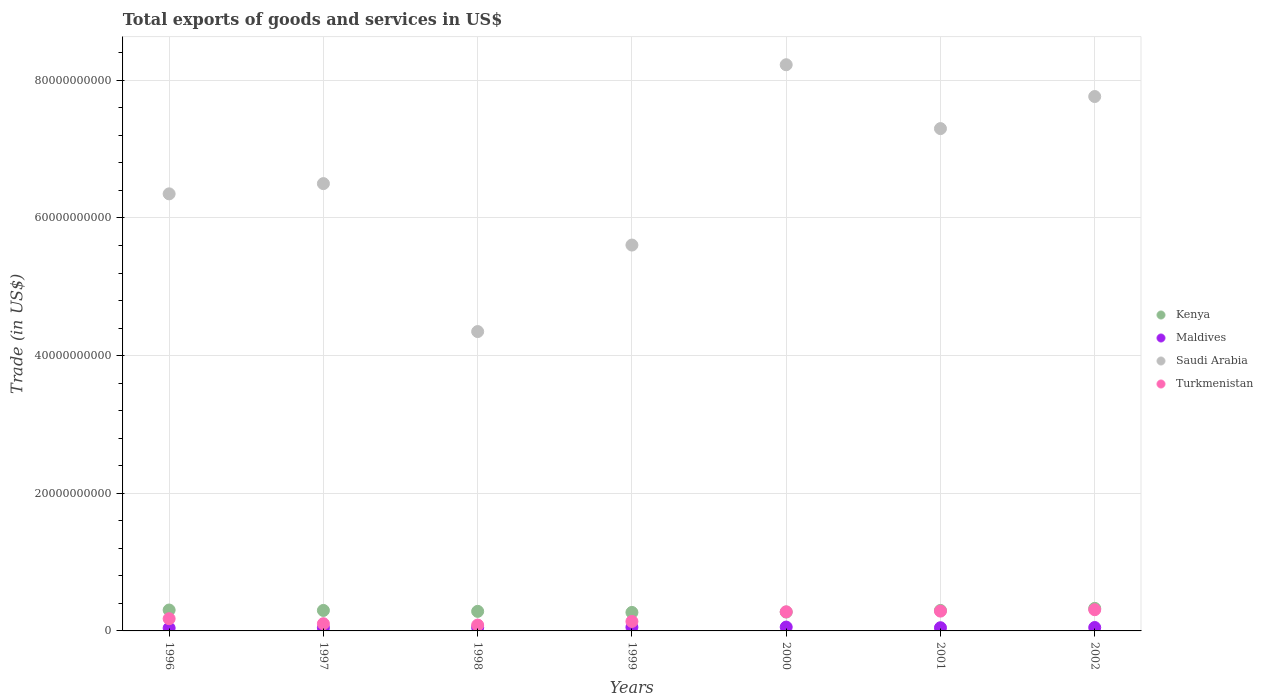Is the number of dotlines equal to the number of legend labels?
Provide a short and direct response. Yes. What is the total exports of goods and services in Kenya in 1996?
Your response must be concise. 3.04e+09. Across all years, what is the maximum total exports of goods and services in Turkmenistan?
Your answer should be very brief. 3.08e+09. Across all years, what is the minimum total exports of goods and services in Maldives?
Provide a short and direct response. 4.13e+08. In which year was the total exports of goods and services in Kenya maximum?
Your response must be concise. 2002. In which year was the total exports of goods and services in Kenya minimum?
Your answer should be very brief. 1999. What is the total total exports of goods and services in Maldives in the graph?
Ensure brevity in your answer.  3.43e+09. What is the difference between the total exports of goods and services in Turkmenistan in 1998 and that in 2000?
Make the answer very short. -1.92e+09. What is the difference between the total exports of goods and services in Maldives in 1998 and the total exports of goods and services in Saudi Arabia in 1996?
Ensure brevity in your answer.  -6.30e+1. What is the average total exports of goods and services in Saudi Arabia per year?
Your answer should be very brief. 6.58e+1. In the year 2002, what is the difference between the total exports of goods and services in Saudi Arabia and total exports of goods and services in Kenya?
Your response must be concise. 7.44e+1. In how many years, is the total exports of goods and services in Turkmenistan greater than 28000000000 US$?
Your answer should be compact. 0. What is the ratio of the total exports of goods and services in Maldives in 1997 to that in 1998?
Provide a succinct answer. 0.93. Is the total exports of goods and services in Kenya in 1999 less than that in 2002?
Provide a succinct answer. Yes. What is the difference between the highest and the second highest total exports of goods and services in Saudi Arabia?
Make the answer very short. 4.62e+09. What is the difference between the highest and the lowest total exports of goods and services in Turkmenistan?
Your response must be concise. 2.23e+09. In how many years, is the total exports of goods and services in Saudi Arabia greater than the average total exports of goods and services in Saudi Arabia taken over all years?
Make the answer very short. 3. Is the sum of the total exports of goods and services in Maldives in 1999 and 2001 greater than the maximum total exports of goods and services in Turkmenistan across all years?
Ensure brevity in your answer.  No. Is it the case that in every year, the sum of the total exports of goods and services in Kenya and total exports of goods and services in Saudi Arabia  is greater than the sum of total exports of goods and services in Maldives and total exports of goods and services in Turkmenistan?
Your answer should be very brief. Yes. Are the values on the major ticks of Y-axis written in scientific E-notation?
Offer a terse response. No. Does the graph contain grids?
Ensure brevity in your answer.  Yes. Where does the legend appear in the graph?
Keep it short and to the point. Center right. How are the legend labels stacked?
Offer a terse response. Vertical. What is the title of the graph?
Your answer should be compact. Total exports of goods and services in US$. What is the label or title of the Y-axis?
Provide a succinct answer. Trade (in US$). What is the Trade (in US$) in Kenya in 1996?
Provide a short and direct response. 3.04e+09. What is the Trade (in US$) of Maldives in 1996?
Give a very brief answer. 4.13e+08. What is the Trade (in US$) of Saudi Arabia in 1996?
Your response must be concise. 6.35e+1. What is the Trade (in US$) in Turkmenistan in 1996?
Your answer should be compact. 1.77e+09. What is the Trade (in US$) of Kenya in 1997?
Your response must be concise. 2.98e+09. What is the Trade (in US$) of Maldives in 1997?
Your answer should be very brief. 4.64e+08. What is the Trade (in US$) of Saudi Arabia in 1997?
Your answer should be very brief. 6.50e+1. What is the Trade (in US$) in Turkmenistan in 1997?
Provide a succinct answer. 1.05e+09. What is the Trade (in US$) of Kenya in 1998?
Make the answer very short. 2.84e+09. What is the Trade (in US$) of Maldives in 1998?
Your answer should be compact. 4.99e+08. What is the Trade (in US$) of Saudi Arabia in 1998?
Give a very brief answer. 4.35e+1. What is the Trade (in US$) in Turkmenistan in 1998?
Make the answer very short. 8.51e+08. What is the Trade (in US$) of Kenya in 1999?
Ensure brevity in your answer.  2.69e+09. What is the Trade (in US$) of Maldives in 1999?
Provide a succinct answer. 5.33e+08. What is the Trade (in US$) in Saudi Arabia in 1999?
Ensure brevity in your answer.  5.61e+1. What is the Trade (in US$) in Turkmenistan in 1999?
Ensure brevity in your answer.  1.38e+09. What is the Trade (in US$) in Kenya in 2000?
Make the answer very short. 2.74e+09. What is the Trade (in US$) in Maldives in 2000?
Provide a succinct answer. 5.59e+08. What is the Trade (in US$) of Saudi Arabia in 2000?
Provide a short and direct response. 8.23e+1. What is the Trade (in US$) in Turkmenistan in 2000?
Offer a terse response. 2.77e+09. What is the Trade (in US$) of Kenya in 2001?
Offer a terse response. 2.98e+09. What is the Trade (in US$) of Maldives in 2001?
Offer a terse response. 4.64e+08. What is the Trade (in US$) in Saudi Arabia in 2001?
Give a very brief answer. 7.30e+1. What is the Trade (in US$) in Turkmenistan in 2001?
Offer a terse response. 2.88e+09. What is the Trade (in US$) in Kenya in 2002?
Provide a succinct answer. 3.27e+09. What is the Trade (in US$) in Maldives in 2002?
Give a very brief answer. 4.95e+08. What is the Trade (in US$) in Saudi Arabia in 2002?
Give a very brief answer. 7.76e+1. What is the Trade (in US$) in Turkmenistan in 2002?
Your response must be concise. 3.08e+09. Across all years, what is the maximum Trade (in US$) in Kenya?
Your answer should be compact. 3.27e+09. Across all years, what is the maximum Trade (in US$) in Maldives?
Offer a very short reply. 5.59e+08. Across all years, what is the maximum Trade (in US$) in Saudi Arabia?
Your answer should be compact. 8.23e+1. Across all years, what is the maximum Trade (in US$) in Turkmenistan?
Make the answer very short. 3.08e+09. Across all years, what is the minimum Trade (in US$) of Kenya?
Provide a succinct answer. 2.69e+09. Across all years, what is the minimum Trade (in US$) of Maldives?
Ensure brevity in your answer.  4.13e+08. Across all years, what is the minimum Trade (in US$) of Saudi Arabia?
Your answer should be compact. 4.35e+1. Across all years, what is the minimum Trade (in US$) in Turkmenistan?
Offer a terse response. 8.51e+08. What is the total Trade (in US$) of Kenya in the graph?
Keep it short and to the point. 2.05e+1. What is the total Trade (in US$) in Maldives in the graph?
Offer a very short reply. 3.43e+09. What is the total Trade (in US$) in Saudi Arabia in the graph?
Ensure brevity in your answer.  4.61e+11. What is the total Trade (in US$) of Turkmenistan in the graph?
Your answer should be very brief. 1.38e+1. What is the difference between the Trade (in US$) of Kenya in 1996 and that in 1997?
Make the answer very short. 6.01e+07. What is the difference between the Trade (in US$) in Maldives in 1996 and that in 1997?
Give a very brief answer. -5.06e+07. What is the difference between the Trade (in US$) in Saudi Arabia in 1996 and that in 1997?
Keep it short and to the point. -1.49e+09. What is the difference between the Trade (in US$) in Turkmenistan in 1996 and that in 1997?
Make the answer very short. 7.29e+08. What is the difference between the Trade (in US$) in Kenya in 1996 and that in 1998?
Your answer should be compact. 1.93e+08. What is the difference between the Trade (in US$) in Maldives in 1996 and that in 1998?
Make the answer very short. -8.62e+07. What is the difference between the Trade (in US$) of Saudi Arabia in 1996 and that in 1998?
Your answer should be compact. 2.00e+1. What is the difference between the Trade (in US$) of Turkmenistan in 1996 and that in 1998?
Provide a short and direct response. 9.24e+08. What is the difference between the Trade (in US$) of Kenya in 1996 and that in 1999?
Offer a terse response. 3.49e+08. What is the difference between the Trade (in US$) of Maldives in 1996 and that in 1999?
Ensure brevity in your answer.  -1.20e+08. What is the difference between the Trade (in US$) of Saudi Arabia in 1996 and that in 1999?
Your response must be concise. 7.44e+09. What is the difference between the Trade (in US$) in Turkmenistan in 1996 and that in 1999?
Keep it short and to the point. 3.99e+08. What is the difference between the Trade (in US$) in Kenya in 1996 and that in 2000?
Ensure brevity in your answer.  2.93e+08. What is the difference between the Trade (in US$) in Maldives in 1996 and that in 2000?
Ensure brevity in your answer.  -1.46e+08. What is the difference between the Trade (in US$) in Saudi Arabia in 1996 and that in 2000?
Provide a succinct answer. -1.88e+1. What is the difference between the Trade (in US$) of Turkmenistan in 1996 and that in 2000?
Give a very brief answer. -1.00e+09. What is the difference between the Trade (in US$) in Kenya in 1996 and that in 2001?
Offer a very short reply. 5.77e+07. What is the difference between the Trade (in US$) in Maldives in 1996 and that in 2001?
Your answer should be compact. -5.13e+07. What is the difference between the Trade (in US$) in Saudi Arabia in 1996 and that in 2001?
Your response must be concise. -9.48e+09. What is the difference between the Trade (in US$) in Turkmenistan in 1996 and that in 2001?
Offer a very short reply. -1.10e+09. What is the difference between the Trade (in US$) of Kenya in 1996 and that in 2002?
Ensure brevity in your answer.  -2.38e+08. What is the difference between the Trade (in US$) of Maldives in 1996 and that in 2002?
Ensure brevity in your answer.  -8.23e+07. What is the difference between the Trade (in US$) in Saudi Arabia in 1996 and that in 2002?
Make the answer very short. -1.41e+1. What is the difference between the Trade (in US$) in Turkmenistan in 1996 and that in 2002?
Offer a very short reply. -1.31e+09. What is the difference between the Trade (in US$) in Kenya in 1997 and that in 1998?
Make the answer very short. 1.33e+08. What is the difference between the Trade (in US$) of Maldives in 1997 and that in 1998?
Provide a succinct answer. -3.56e+07. What is the difference between the Trade (in US$) in Saudi Arabia in 1997 and that in 1998?
Offer a very short reply. 2.15e+1. What is the difference between the Trade (in US$) in Turkmenistan in 1997 and that in 1998?
Provide a short and direct response. 1.95e+08. What is the difference between the Trade (in US$) in Kenya in 1997 and that in 1999?
Provide a succinct answer. 2.89e+08. What is the difference between the Trade (in US$) in Maldives in 1997 and that in 1999?
Make the answer very short. -6.97e+07. What is the difference between the Trade (in US$) of Saudi Arabia in 1997 and that in 1999?
Offer a very short reply. 8.93e+09. What is the difference between the Trade (in US$) of Turkmenistan in 1997 and that in 1999?
Give a very brief answer. -3.30e+08. What is the difference between the Trade (in US$) of Kenya in 1997 and that in 2000?
Offer a terse response. 2.33e+08. What is the difference between the Trade (in US$) of Maldives in 1997 and that in 2000?
Offer a terse response. -9.50e+07. What is the difference between the Trade (in US$) in Saudi Arabia in 1997 and that in 2000?
Provide a succinct answer. -1.73e+1. What is the difference between the Trade (in US$) of Turkmenistan in 1997 and that in 2000?
Offer a terse response. -1.73e+09. What is the difference between the Trade (in US$) in Kenya in 1997 and that in 2001?
Give a very brief answer. -2.40e+06. What is the difference between the Trade (in US$) of Maldives in 1997 and that in 2001?
Your answer should be compact. -6.95e+05. What is the difference between the Trade (in US$) of Saudi Arabia in 1997 and that in 2001?
Offer a terse response. -7.99e+09. What is the difference between the Trade (in US$) of Turkmenistan in 1997 and that in 2001?
Your answer should be very brief. -1.83e+09. What is the difference between the Trade (in US$) in Kenya in 1997 and that in 2002?
Give a very brief answer. -2.98e+08. What is the difference between the Trade (in US$) in Maldives in 1997 and that in 2002?
Your response must be concise. -3.17e+07. What is the difference between the Trade (in US$) of Saudi Arabia in 1997 and that in 2002?
Make the answer very short. -1.27e+1. What is the difference between the Trade (in US$) in Turkmenistan in 1997 and that in 2002?
Give a very brief answer. -2.04e+09. What is the difference between the Trade (in US$) in Kenya in 1998 and that in 1999?
Your answer should be compact. 1.56e+08. What is the difference between the Trade (in US$) in Maldives in 1998 and that in 1999?
Ensure brevity in your answer.  -3.41e+07. What is the difference between the Trade (in US$) in Saudi Arabia in 1998 and that in 1999?
Your answer should be very brief. -1.26e+1. What is the difference between the Trade (in US$) in Turkmenistan in 1998 and that in 1999?
Make the answer very short. -5.25e+08. What is the difference between the Trade (in US$) in Kenya in 1998 and that in 2000?
Offer a terse response. 9.99e+07. What is the difference between the Trade (in US$) in Maldives in 1998 and that in 2000?
Your answer should be compact. -5.94e+07. What is the difference between the Trade (in US$) of Saudi Arabia in 1998 and that in 2000?
Offer a very short reply. -3.88e+1. What is the difference between the Trade (in US$) of Turkmenistan in 1998 and that in 2000?
Provide a short and direct response. -1.92e+09. What is the difference between the Trade (in US$) in Kenya in 1998 and that in 2001?
Make the answer very short. -1.35e+08. What is the difference between the Trade (in US$) in Maldives in 1998 and that in 2001?
Your answer should be very brief. 3.49e+07. What is the difference between the Trade (in US$) in Saudi Arabia in 1998 and that in 2001?
Your answer should be very brief. -2.95e+1. What is the difference between the Trade (in US$) of Turkmenistan in 1998 and that in 2001?
Your answer should be very brief. -2.03e+09. What is the difference between the Trade (in US$) in Kenya in 1998 and that in 2002?
Provide a succinct answer. -4.31e+08. What is the difference between the Trade (in US$) in Maldives in 1998 and that in 2002?
Ensure brevity in your answer.  3.90e+06. What is the difference between the Trade (in US$) in Saudi Arabia in 1998 and that in 2002?
Your response must be concise. -3.41e+1. What is the difference between the Trade (in US$) of Turkmenistan in 1998 and that in 2002?
Offer a terse response. -2.23e+09. What is the difference between the Trade (in US$) in Kenya in 1999 and that in 2000?
Your answer should be compact. -5.62e+07. What is the difference between the Trade (in US$) of Maldives in 1999 and that in 2000?
Provide a succinct answer. -2.53e+07. What is the difference between the Trade (in US$) of Saudi Arabia in 1999 and that in 2000?
Your answer should be very brief. -2.62e+1. What is the difference between the Trade (in US$) in Turkmenistan in 1999 and that in 2000?
Offer a terse response. -1.40e+09. What is the difference between the Trade (in US$) in Kenya in 1999 and that in 2001?
Give a very brief answer. -2.91e+08. What is the difference between the Trade (in US$) of Maldives in 1999 and that in 2001?
Keep it short and to the point. 6.90e+07. What is the difference between the Trade (in US$) of Saudi Arabia in 1999 and that in 2001?
Your response must be concise. -1.69e+1. What is the difference between the Trade (in US$) of Turkmenistan in 1999 and that in 2001?
Ensure brevity in your answer.  -1.50e+09. What is the difference between the Trade (in US$) of Kenya in 1999 and that in 2002?
Provide a succinct answer. -5.87e+08. What is the difference between the Trade (in US$) in Maldives in 1999 and that in 2002?
Keep it short and to the point. 3.80e+07. What is the difference between the Trade (in US$) in Saudi Arabia in 1999 and that in 2002?
Your answer should be very brief. -2.16e+1. What is the difference between the Trade (in US$) in Turkmenistan in 1999 and that in 2002?
Provide a succinct answer. -1.71e+09. What is the difference between the Trade (in US$) in Kenya in 2000 and that in 2001?
Keep it short and to the point. -2.35e+08. What is the difference between the Trade (in US$) in Maldives in 2000 and that in 2001?
Give a very brief answer. 9.43e+07. What is the difference between the Trade (in US$) in Saudi Arabia in 2000 and that in 2001?
Ensure brevity in your answer.  9.28e+09. What is the difference between the Trade (in US$) of Turkmenistan in 2000 and that in 2001?
Keep it short and to the point. -1.03e+08. What is the difference between the Trade (in US$) in Kenya in 2000 and that in 2002?
Your answer should be compact. -5.31e+08. What is the difference between the Trade (in US$) of Maldives in 2000 and that in 2002?
Keep it short and to the point. 6.33e+07. What is the difference between the Trade (in US$) in Saudi Arabia in 2000 and that in 2002?
Your response must be concise. 4.62e+09. What is the difference between the Trade (in US$) in Turkmenistan in 2000 and that in 2002?
Give a very brief answer. -3.07e+08. What is the difference between the Trade (in US$) of Kenya in 2001 and that in 2002?
Ensure brevity in your answer.  -2.96e+08. What is the difference between the Trade (in US$) in Maldives in 2001 and that in 2002?
Make the answer very short. -3.10e+07. What is the difference between the Trade (in US$) in Saudi Arabia in 2001 and that in 2002?
Give a very brief answer. -4.66e+09. What is the difference between the Trade (in US$) of Turkmenistan in 2001 and that in 2002?
Your answer should be compact. -2.04e+08. What is the difference between the Trade (in US$) of Kenya in 1996 and the Trade (in US$) of Maldives in 1997?
Your answer should be very brief. 2.57e+09. What is the difference between the Trade (in US$) in Kenya in 1996 and the Trade (in US$) in Saudi Arabia in 1997?
Provide a succinct answer. -6.20e+1. What is the difference between the Trade (in US$) in Kenya in 1996 and the Trade (in US$) in Turkmenistan in 1997?
Your answer should be very brief. 1.99e+09. What is the difference between the Trade (in US$) of Maldives in 1996 and the Trade (in US$) of Saudi Arabia in 1997?
Your answer should be very brief. -6.46e+1. What is the difference between the Trade (in US$) of Maldives in 1996 and the Trade (in US$) of Turkmenistan in 1997?
Your answer should be compact. -6.33e+08. What is the difference between the Trade (in US$) in Saudi Arabia in 1996 and the Trade (in US$) in Turkmenistan in 1997?
Provide a short and direct response. 6.25e+1. What is the difference between the Trade (in US$) of Kenya in 1996 and the Trade (in US$) of Maldives in 1998?
Offer a terse response. 2.54e+09. What is the difference between the Trade (in US$) in Kenya in 1996 and the Trade (in US$) in Saudi Arabia in 1998?
Provide a short and direct response. -4.05e+1. What is the difference between the Trade (in US$) in Kenya in 1996 and the Trade (in US$) in Turkmenistan in 1998?
Your answer should be very brief. 2.18e+09. What is the difference between the Trade (in US$) in Maldives in 1996 and the Trade (in US$) in Saudi Arabia in 1998?
Offer a terse response. -4.31e+1. What is the difference between the Trade (in US$) of Maldives in 1996 and the Trade (in US$) of Turkmenistan in 1998?
Your answer should be very brief. -4.38e+08. What is the difference between the Trade (in US$) of Saudi Arabia in 1996 and the Trade (in US$) of Turkmenistan in 1998?
Offer a very short reply. 6.27e+1. What is the difference between the Trade (in US$) of Kenya in 1996 and the Trade (in US$) of Maldives in 1999?
Give a very brief answer. 2.50e+09. What is the difference between the Trade (in US$) in Kenya in 1996 and the Trade (in US$) in Saudi Arabia in 1999?
Your response must be concise. -5.30e+1. What is the difference between the Trade (in US$) in Kenya in 1996 and the Trade (in US$) in Turkmenistan in 1999?
Your answer should be very brief. 1.66e+09. What is the difference between the Trade (in US$) in Maldives in 1996 and the Trade (in US$) in Saudi Arabia in 1999?
Your answer should be very brief. -5.56e+1. What is the difference between the Trade (in US$) of Maldives in 1996 and the Trade (in US$) of Turkmenistan in 1999?
Provide a succinct answer. -9.63e+08. What is the difference between the Trade (in US$) of Saudi Arabia in 1996 and the Trade (in US$) of Turkmenistan in 1999?
Keep it short and to the point. 6.21e+1. What is the difference between the Trade (in US$) in Kenya in 1996 and the Trade (in US$) in Maldives in 2000?
Make the answer very short. 2.48e+09. What is the difference between the Trade (in US$) in Kenya in 1996 and the Trade (in US$) in Saudi Arabia in 2000?
Give a very brief answer. -7.92e+1. What is the difference between the Trade (in US$) in Kenya in 1996 and the Trade (in US$) in Turkmenistan in 2000?
Provide a succinct answer. 2.62e+08. What is the difference between the Trade (in US$) of Maldives in 1996 and the Trade (in US$) of Saudi Arabia in 2000?
Ensure brevity in your answer.  -8.18e+1. What is the difference between the Trade (in US$) of Maldives in 1996 and the Trade (in US$) of Turkmenistan in 2000?
Offer a very short reply. -2.36e+09. What is the difference between the Trade (in US$) in Saudi Arabia in 1996 and the Trade (in US$) in Turkmenistan in 2000?
Offer a very short reply. 6.07e+1. What is the difference between the Trade (in US$) of Kenya in 1996 and the Trade (in US$) of Maldives in 2001?
Provide a short and direct response. 2.57e+09. What is the difference between the Trade (in US$) in Kenya in 1996 and the Trade (in US$) in Saudi Arabia in 2001?
Provide a succinct answer. -6.99e+1. What is the difference between the Trade (in US$) of Kenya in 1996 and the Trade (in US$) of Turkmenistan in 2001?
Offer a terse response. 1.59e+08. What is the difference between the Trade (in US$) of Maldives in 1996 and the Trade (in US$) of Saudi Arabia in 2001?
Your answer should be very brief. -7.26e+1. What is the difference between the Trade (in US$) in Maldives in 1996 and the Trade (in US$) in Turkmenistan in 2001?
Your answer should be very brief. -2.46e+09. What is the difference between the Trade (in US$) in Saudi Arabia in 1996 and the Trade (in US$) in Turkmenistan in 2001?
Provide a succinct answer. 6.06e+1. What is the difference between the Trade (in US$) of Kenya in 1996 and the Trade (in US$) of Maldives in 2002?
Your answer should be compact. 2.54e+09. What is the difference between the Trade (in US$) in Kenya in 1996 and the Trade (in US$) in Saudi Arabia in 2002?
Ensure brevity in your answer.  -7.46e+1. What is the difference between the Trade (in US$) in Kenya in 1996 and the Trade (in US$) in Turkmenistan in 2002?
Offer a terse response. -4.54e+07. What is the difference between the Trade (in US$) in Maldives in 1996 and the Trade (in US$) in Saudi Arabia in 2002?
Provide a succinct answer. -7.72e+1. What is the difference between the Trade (in US$) in Maldives in 1996 and the Trade (in US$) in Turkmenistan in 2002?
Give a very brief answer. -2.67e+09. What is the difference between the Trade (in US$) of Saudi Arabia in 1996 and the Trade (in US$) of Turkmenistan in 2002?
Provide a succinct answer. 6.04e+1. What is the difference between the Trade (in US$) of Kenya in 1997 and the Trade (in US$) of Maldives in 1998?
Provide a succinct answer. 2.48e+09. What is the difference between the Trade (in US$) in Kenya in 1997 and the Trade (in US$) in Saudi Arabia in 1998?
Your response must be concise. -4.05e+1. What is the difference between the Trade (in US$) of Kenya in 1997 and the Trade (in US$) of Turkmenistan in 1998?
Offer a very short reply. 2.12e+09. What is the difference between the Trade (in US$) in Maldives in 1997 and the Trade (in US$) in Saudi Arabia in 1998?
Give a very brief answer. -4.30e+1. What is the difference between the Trade (in US$) in Maldives in 1997 and the Trade (in US$) in Turkmenistan in 1998?
Make the answer very short. -3.87e+08. What is the difference between the Trade (in US$) in Saudi Arabia in 1997 and the Trade (in US$) in Turkmenistan in 1998?
Make the answer very short. 6.41e+1. What is the difference between the Trade (in US$) in Kenya in 1997 and the Trade (in US$) in Maldives in 1999?
Provide a short and direct response. 2.44e+09. What is the difference between the Trade (in US$) of Kenya in 1997 and the Trade (in US$) of Saudi Arabia in 1999?
Your answer should be compact. -5.31e+1. What is the difference between the Trade (in US$) in Kenya in 1997 and the Trade (in US$) in Turkmenistan in 1999?
Ensure brevity in your answer.  1.60e+09. What is the difference between the Trade (in US$) of Maldives in 1997 and the Trade (in US$) of Saudi Arabia in 1999?
Keep it short and to the point. -5.56e+1. What is the difference between the Trade (in US$) of Maldives in 1997 and the Trade (in US$) of Turkmenistan in 1999?
Keep it short and to the point. -9.12e+08. What is the difference between the Trade (in US$) of Saudi Arabia in 1997 and the Trade (in US$) of Turkmenistan in 1999?
Give a very brief answer. 6.36e+1. What is the difference between the Trade (in US$) of Kenya in 1997 and the Trade (in US$) of Maldives in 2000?
Offer a very short reply. 2.42e+09. What is the difference between the Trade (in US$) of Kenya in 1997 and the Trade (in US$) of Saudi Arabia in 2000?
Provide a succinct answer. -7.93e+1. What is the difference between the Trade (in US$) in Kenya in 1997 and the Trade (in US$) in Turkmenistan in 2000?
Provide a succinct answer. 2.01e+08. What is the difference between the Trade (in US$) of Maldives in 1997 and the Trade (in US$) of Saudi Arabia in 2000?
Make the answer very short. -8.18e+1. What is the difference between the Trade (in US$) in Maldives in 1997 and the Trade (in US$) in Turkmenistan in 2000?
Offer a very short reply. -2.31e+09. What is the difference between the Trade (in US$) in Saudi Arabia in 1997 and the Trade (in US$) in Turkmenistan in 2000?
Provide a succinct answer. 6.22e+1. What is the difference between the Trade (in US$) in Kenya in 1997 and the Trade (in US$) in Maldives in 2001?
Make the answer very short. 2.51e+09. What is the difference between the Trade (in US$) of Kenya in 1997 and the Trade (in US$) of Saudi Arabia in 2001?
Ensure brevity in your answer.  -7.00e+1. What is the difference between the Trade (in US$) of Kenya in 1997 and the Trade (in US$) of Turkmenistan in 2001?
Offer a terse response. 9.85e+07. What is the difference between the Trade (in US$) in Maldives in 1997 and the Trade (in US$) in Saudi Arabia in 2001?
Keep it short and to the point. -7.25e+1. What is the difference between the Trade (in US$) in Maldives in 1997 and the Trade (in US$) in Turkmenistan in 2001?
Provide a short and direct response. -2.41e+09. What is the difference between the Trade (in US$) of Saudi Arabia in 1997 and the Trade (in US$) of Turkmenistan in 2001?
Offer a very short reply. 6.21e+1. What is the difference between the Trade (in US$) of Kenya in 1997 and the Trade (in US$) of Maldives in 2002?
Make the answer very short. 2.48e+09. What is the difference between the Trade (in US$) of Kenya in 1997 and the Trade (in US$) of Saudi Arabia in 2002?
Ensure brevity in your answer.  -7.47e+1. What is the difference between the Trade (in US$) of Kenya in 1997 and the Trade (in US$) of Turkmenistan in 2002?
Make the answer very short. -1.06e+08. What is the difference between the Trade (in US$) of Maldives in 1997 and the Trade (in US$) of Saudi Arabia in 2002?
Give a very brief answer. -7.72e+1. What is the difference between the Trade (in US$) of Maldives in 1997 and the Trade (in US$) of Turkmenistan in 2002?
Your response must be concise. -2.62e+09. What is the difference between the Trade (in US$) of Saudi Arabia in 1997 and the Trade (in US$) of Turkmenistan in 2002?
Your answer should be very brief. 6.19e+1. What is the difference between the Trade (in US$) of Kenya in 1998 and the Trade (in US$) of Maldives in 1999?
Your response must be concise. 2.31e+09. What is the difference between the Trade (in US$) of Kenya in 1998 and the Trade (in US$) of Saudi Arabia in 1999?
Offer a very short reply. -5.32e+1. What is the difference between the Trade (in US$) of Kenya in 1998 and the Trade (in US$) of Turkmenistan in 1999?
Ensure brevity in your answer.  1.47e+09. What is the difference between the Trade (in US$) of Maldives in 1998 and the Trade (in US$) of Saudi Arabia in 1999?
Give a very brief answer. -5.56e+1. What is the difference between the Trade (in US$) of Maldives in 1998 and the Trade (in US$) of Turkmenistan in 1999?
Offer a terse response. -8.77e+08. What is the difference between the Trade (in US$) in Saudi Arabia in 1998 and the Trade (in US$) in Turkmenistan in 1999?
Keep it short and to the point. 4.21e+1. What is the difference between the Trade (in US$) of Kenya in 1998 and the Trade (in US$) of Maldives in 2000?
Offer a very short reply. 2.28e+09. What is the difference between the Trade (in US$) of Kenya in 1998 and the Trade (in US$) of Saudi Arabia in 2000?
Offer a terse response. -7.94e+1. What is the difference between the Trade (in US$) in Kenya in 1998 and the Trade (in US$) in Turkmenistan in 2000?
Offer a terse response. 6.87e+07. What is the difference between the Trade (in US$) of Maldives in 1998 and the Trade (in US$) of Saudi Arabia in 2000?
Provide a short and direct response. -8.18e+1. What is the difference between the Trade (in US$) of Maldives in 1998 and the Trade (in US$) of Turkmenistan in 2000?
Your answer should be very brief. -2.27e+09. What is the difference between the Trade (in US$) of Saudi Arabia in 1998 and the Trade (in US$) of Turkmenistan in 2000?
Offer a very short reply. 4.07e+1. What is the difference between the Trade (in US$) in Kenya in 1998 and the Trade (in US$) in Maldives in 2001?
Offer a very short reply. 2.38e+09. What is the difference between the Trade (in US$) of Kenya in 1998 and the Trade (in US$) of Saudi Arabia in 2001?
Provide a succinct answer. -7.01e+1. What is the difference between the Trade (in US$) in Kenya in 1998 and the Trade (in US$) in Turkmenistan in 2001?
Ensure brevity in your answer.  -3.43e+07. What is the difference between the Trade (in US$) in Maldives in 1998 and the Trade (in US$) in Saudi Arabia in 2001?
Offer a terse response. -7.25e+1. What is the difference between the Trade (in US$) in Maldives in 1998 and the Trade (in US$) in Turkmenistan in 2001?
Ensure brevity in your answer.  -2.38e+09. What is the difference between the Trade (in US$) in Saudi Arabia in 1998 and the Trade (in US$) in Turkmenistan in 2001?
Offer a terse response. 4.06e+1. What is the difference between the Trade (in US$) of Kenya in 1998 and the Trade (in US$) of Maldives in 2002?
Ensure brevity in your answer.  2.35e+09. What is the difference between the Trade (in US$) in Kenya in 1998 and the Trade (in US$) in Saudi Arabia in 2002?
Provide a short and direct response. -7.48e+1. What is the difference between the Trade (in US$) in Kenya in 1998 and the Trade (in US$) in Turkmenistan in 2002?
Offer a terse response. -2.38e+08. What is the difference between the Trade (in US$) of Maldives in 1998 and the Trade (in US$) of Saudi Arabia in 2002?
Keep it short and to the point. -7.71e+1. What is the difference between the Trade (in US$) of Maldives in 1998 and the Trade (in US$) of Turkmenistan in 2002?
Make the answer very short. -2.58e+09. What is the difference between the Trade (in US$) of Saudi Arabia in 1998 and the Trade (in US$) of Turkmenistan in 2002?
Make the answer very short. 4.04e+1. What is the difference between the Trade (in US$) of Kenya in 1999 and the Trade (in US$) of Maldives in 2000?
Offer a terse response. 2.13e+09. What is the difference between the Trade (in US$) of Kenya in 1999 and the Trade (in US$) of Saudi Arabia in 2000?
Your answer should be compact. -7.96e+1. What is the difference between the Trade (in US$) in Kenya in 1999 and the Trade (in US$) in Turkmenistan in 2000?
Your response must be concise. -8.74e+07. What is the difference between the Trade (in US$) in Maldives in 1999 and the Trade (in US$) in Saudi Arabia in 2000?
Your answer should be compact. -8.17e+1. What is the difference between the Trade (in US$) of Maldives in 1999 and the Trade (in US$) of Turkmenistan in 2000?
Provide a succinct answer. -2.24e+09. What is the difference between the Trade (in US$) in Saudi Arabia in 1999 and the Trade (in US$) in Turkmenistan in 2000?
Make the answer very short. 5.33e+1. What is the difference between the Trade (in US$) of Kenya in 1999 and the Trade (in US$) of Maldives in 2001?
Your response must be concise. 2.22e+09. What is the difference between the Trade (in US$) of Kenya in 1999 and the Trade (in US$) of Saudi Arabia in 2001?
Keep it short and to the point. -7.03e+1. What is the difference between the Trade (in US$) in Kenya in 1999 and the Trade (in US$) in Turkmenistan in 2001?
Your answer should be compact. -1.90e+08. What is the difference between the Trade (in US$) in Maldives in 1999 and the Trade (in US$) in Saudi Arabia in 2001?
Provide a succinct answer. -7.24e+1. What is the difference between the Trade (in US$) of Maldives in 1999 and the Trade (in US$) of Turkmenistan in 2001?
Give a very brief answer. -2.34e+09. What is the difference between the Trade (in US$) of Saudi Arabia in 1999 and the Trade (in US$) of Turkmenistan in 2001?
Keep it short and to the point. 5.32e+1. What is the difference between the Trade (in US$) in Kenya in 1999 and the Trade (in US$) in Maldives in 2002?
Give a very brief answer. 2.19e+09. What is the difference between the Trade (in US$) in Kenya in 1999 and the Trade (in US$) in Saudi Arabia in 2002?
Keep it short and to the point. -7.50e+1. What is the difference between the Trade (in US$) of Kenya in 1999 and the Trade (in US$) of Turkmenistan in 2002?
Keep it short and to the point. -3.94e+08. What is the difference between the Trade (in US$) in Maldives in 1999 and the Trade (in US$) in Saudi Arabia in 2002?
Your response must be concise. -7.71e+1. What is the difference between the Trade (in US$) in Maldives in 1999 and the Trade (in US$) in Turkmenistan in 2002?
Make the answer very short. -2.55e+09. What is the difference between the Trade (in US$) of Saudi Arabia in 1999 and the Trade (in US$) of Turkmenistan in 2002?
Provide a succinct answer. 5.30e+1. What is the difference between the Trade (in US$) in Kenya in 2000 and the Trade (in US$) in Maldives in 2001?
Keep it short and to the point. 2.28e+09. What is the difference between the Trade (in US$) of Kenya in 2000 and the Trade (in US$) of Saudi Arabia in 2001?
Offer a very short reply. -7.02e+1. What is the difference between the Trade (in US$) of Kenya in 2000 and the Trade (in US$) of Turkmenistan in 2001?
Ensure brevity in your answer.  -1.34e+08. What is the difference between the Trade (in US$) in Maldives in 2000 and the Trade (in US$) in Saudi Arabia in 2001?
Offer a terse response. -7.24e+1. What is the difference between the Trade (in US$) of Maldives in 2000 and the Trade (in US$) of Turkmenistan in 2001?
Your answer should be compact. -2.32e+09. What is the difference between the Trade (in US$) of Saudi Arabia in 2000 and the Trade (in US$) of Turkmenistan in 2001?
Provide a short and direct response. 7.94e+1. What is the difference between the Trade (in US$) of Kenya in 2000 and the Trade (in US$) of Maldives in 2002?
Make the answer very short. 2.25e+09. What is the difference between the Trade (in US$) in Kenya in 2000 and the Trade (in US$) in Saudi Arabia in 2002?
Your answer should be compact. -7.49e+1. What is the difference between the Trade (in US$) in Kenya in 2000 and the Trade (in US$) in Turkmenistan in 2002?
Ensure brevity in your answer.  -3.38e+08. What is the difference between the Trade (in US$) of Maldives in 2000 and the Trade (in US$) of Saudi Arabia in 2002?
Keep it short and to the point. -7.71e+1. What is the difference between the Trade (in US$) of Maldives in 2000 and the Trade (in US$) of Turkmenistan in 2002?
Your response must be concise. -2.52e+09. What is the difference between the Trade (in US$) in Saudi Arabia in 2000 and the Trade (in US$) in Turkmenistan in 2002?
Give a very brief answer. 7.92e+1. What is the difference between the Trade (in US$) in Kenya in 2001 and the Trade (in US$) in Maldives in 2002?
Keep it short and to the point. 2.48e+09. What is the difference between the Trade (in US$) in Kenya in 2001 and the Trade (in US$) in Saudi Arabia in 2002?
Offer a terse response. -7.47e+1. What is the difference between the Trade (in US$) of Kenya in 2001 and the Trade (in US$) of Turkmenistan in 2002?
Provide a succinct answer. -1.03e+08. What is the difference between the Trade (in US$) in Maldives in 2001 and the Trade (in US$) in Saudi Arabia in 2002?
Offer a terse response. -7.72e+1. What is the difference between the Trade (in US$) in Maldives in 2001 and the Trade (in US$) in Turkmenistan in 2002?
Give a very brief answer. -2.62e+09. What is the difference between the Trade (in US$) in Saudi Arabia in 2001 and the Trade (in US$) in Turkmenistan in 2002?
Your answer should be very brief. 6.99e+1. What is the average Trade (in US$) in Kenya per year?
Keep it short and to the point. 2.93e+09. What is the average Trade (in US$) in Maldives per year?
Your response must be concise. 4.90e+08. What is the average Trade (in US$) of Saudi Arabia per year?
Give a very brief answer. 6.58e+1. What is the average Trade (in US$) in Turkmenistan per year?
Provide a short and direct response. 1.97e+09. In the year 1996, what is the difference between the Trade (in US$) of Kenya and Trade (in US$) of Maldives?
Ensure brevity in your answer.  2.62e+09. In the year 1996, what is the difference between the Trade (in US$) of Kenya and Trade (in US$) of Saudi Arabia?
Offer a very short reply. -6.05e+1. In the year 1996, what is the difference between the Trade (in US$) in Kenya and Trade (in US$) in Turkmenistan?
Provide a short and direct response. 1.26e+09. In the year 1996, what is the difference between the Trade (in US$) of Maldives and Trade (in US$) of Saudi Arabia?
Your answer should be compact. -6.31e+1. In the year 1996, what is the difference between the Trade (in US$) in Maldives and Trade (in US$) in Turkmenistan?
Make the answer very short. -1.36e+09. In the year 1996, what is the difference between the Trade (in US$) of Saudi Arabia and Trade (in US$) of Turkmenistan?
Your response must be concise. 6.17e+1. In the year 1997, what is the difference between the Trade (in US$) of Kenya and Trade (in US$) of Maldives?
Ensure brevity in your answer.  2.51e+09. In the year 1997, what is the difference between the Trade (in US$) of Kenya and Trade (in US$) of Saudi Arabia?
Provide a short and direct response. -6.20e+1. In the year 1997, what is the difference between the Trade (in US$) of Kenya and Trade (in US$) of Turkmenistan?
Make the answer very short. 1.93e+09. In the year 1997, what is the difference between the Trade (in US$) in Maldives and Trade (in US$) in Saudi Arabia?
Give a very brief answer. -6.45e+1. In the year 1997, what is the difference between the Trade (in US$) of Maldives and Trade (in US$) of Turkmenistan?
Make the answer very short. -5.82e+08. In the year 1997, what is the difference between the Trade (in US$) in Saudi Arabia and Trade (in US$) in Turkmenistan?
Your answer should be compact. 6.39e+1. In the year 1998, what is the difference between the Trade (in US$) in Kenya and Trade (in US$) in Maldives?
Offer a very short reply. 2.34e+09. In the year 1998, what is the difference between the Trade (in US$) in Kenya and Trade (in US$) in Saudi Arabia?
Your answer should be very brief. -4.07e+1. In the year 1998, what is the difference between the Trade (in US$) in Kenya and Trade (in US$) in Turkmenistan?
Offer a terse response. 1.99e+09. In the year 1998, what is the difference between the Trade (in US$) of Maldives and Trade (in US$) of Saudi Arabia?
Offer a terse response. -4.30e+1. In the year 1998, what is the difference between the Trade (in US$) in Maldives and Trade (in US$) in Turkmenistan?
Ensure brevity in your answer.  -3.52e+08. In the year 1998, what is the difference between the Trade (in US$) of Saudi Arabia and Trade (in US$) of Turkmenistan?
Provide a succinct answer. 4.26e+1. In the year 1999, what is the difference between the Trade (in US$) in Kenya and Trade (in US$) in Maldives?
Keep it short and to the point. 2.15e+09. In the year 1999, what is the difference between the Trade (in US$) in Kenya and Trade (in US$) in Saudi Arabia?
Provide a succinct answer. -5.34e+1. In the year 1999, what is the difference between the Trade (in US$) of Kenya and Trade (in US$) of Turkmenistan?
Make the answer very short. 1.31e+09. In the year 1999, what is the difference between the Trade (in US$) in Maldives and Trade (in US$) in Saudi Arabia?
Your answer should be compact. -5.55e+1. In the year 1999, what is the difference between the Trade (in US$) of Maldives and Trade (in US$) of Turkmenistan?
Keep it short and to the point. -8.43e+08. In the year 1999, what is the difference between the Trade (in US$) of Saudi Arabia and Trade (in US$) of Turkmenistan?
Provide a short and direct response. 5.47e+1. In the year 2000, what is the difference between the Trade (in US$) of Kenya and Trade (in US$) of Maldives?
Ensure brevity in your answer.  2.18e+09. In the year 2000, what is the difference between the Trade (in US$) in Kenya and Trade (in US$) in Saudi Arabia?
Offer a very short reply. -7.95e+1. In the year 2000, what is the difference between the Trade (in US$) of Kenya and Trade (in US$) of Turkmenistan?
Your answer should be compact. -3.12e+07. In the year 2000, what is the difference between the Trade (in US$) of Maldives and Trade (in US$) of Saudi Arabia?
Provide a short and direct response. -8.17e+1. In the year 2000, what is the difference between the Trade (in US$) in Maldives and Trade (in US$) in Turkmenistan?
Your response must be concise. -2.22e+09. In the year 2000, what is the difference between the Trade (in US$) in Saudi Arabia and Trade (in US$) in Turkmenistan?
Offer a terse response. 7.95e+1. In the year 2001, what is the difference between the Trade (in US$) in Kenya and Trade (in US$) in Maldives?
Ensure brevity in your answer.  2.51e+09. In the year 2001, what is the difference between the Trade (in US$) of Kenya and Trade (in US$) of Saudi Arabia?
Your answer should be compact. -7.00e+1. In the year 2001, what is the difference between the Trade (in US$) of Kenya and Trade (in US$) of Turkmenistan?
Your answer should be compact. 1.01e+08. In the year 2001, what is the difference between the Trade (in US$) of Maldives and Trade (in US$) of Saudi Arabia?
Your answer should be compact. -7.25e+1. In the year 2001, what is the difference between the Trade (in US$) of Maldives and Trade (in US$) of Turkmenistan?
Make the answer very short. -2.41e+09. In the year 2001, what is the difference between the Trade (in US$) in Saudi Arabia and Trade (in US$) in Turkmenistan?
Offer a very short reply. 7.01e+1. In the year 2002, what is the difference between the Trade (in US$) in Kenya and Trade (in US$) in Maldives?
Your response must be concise. 2.78e+09. In the year 2002, what is the difference between the Trade (in US$) in Kenya and Trade (in US$) in Saudi Arabia?
Provide a short and direct response. -7.44e+1. In the year 2002, what is the difference between the Trade (in US$) in Kenya and Trade (in US$) in Turkmenistan?
Provide a succinct answer. 1.93e+08. In the year 2002, what is the difference between the Trade (in US$) of Maldives and Trade (in US$) of Saudi Arabia?
Your response must be concise. -7.71e+1. In the year 2002, what is the difference between the Trade (in US$) of Maldives and Trade (in US$) of Turkmenistan?
Give a very brief answer. -2.59e+09. In the year 2002, what is the difference between the Trade (in US$) of Saudi Arabia and Trade (in US$) of Turkmenistan?
Make the answer very short. 7.46e+1. What is the ratio of the Trade (in US$) in Kenya in 1996 to that in 1997?
Offer a very short reply. 1.02. What is the ratio of the Trade (in US$) in Maldives in 1996 to that in 1997?
Offer a terse response. 0.89. What is the ratio of the Trade (in US$) of Saudi Arabia in 1996 to that in 1997?
Make the answer very short. 0.98. What is the ratio of the Trade (in US$) of Turkmenistan in 1996 to that in 1997?
Provide a short and direct response. 1.7. What is the ratio of the Trade (in US$) in Kenya in 1996 to that in 1998?
Your answer should be compact. 1.07. What is the ratio of the Trade (in US$) of Maldives in 1996 to that in 1998?
Your response must be concise. 0.83. What is the ratio of the Trade (in US$) of Saudi Arabia in 1996 to that in 1998?
Your answer should be compact. 1.46. What is the ratio of the Trade (in US$) of Turkmenistan in 1996 to that in 1998?
Your response must be concise. 2.09. What is the ratio of the Trade (in US$) of Kenya in 1996 to that in 1999?
Your response must be concise. 1.13. What is the ratio of the Trade (in US$) in Maldives in 1996 to that in 1999?
Your response must be concise. 0.77. What is the ratio of the Trade (in US$) in Saudi Arabia in 1996 to that in 1999?
Your response must be concise. 1.13. What is the ratio of the Trade (in US$) of Turkmenistan in 1996 to that in 1999?
Ensure brevity in your answer.  1.29. What is the ratio of the Trade (in US$) in Kenya in 1996 to that in 2000?
Your response must be concise. 1.11. What is the ratio of the Trade (in US$) in Maldives in 1996 to that in 2000?
Make the answer very short. 0.74. What is the ratio of the Trade (in US$) of Saudi Arabia in 1996 to that in 2000?
Offer a terse response. 0.77. What is the ratio of the Trade (in US$) of Turkmenistan in 1996 to that in 2000?
Provide a short and direct response. 0.64. What is the ratio of the Trade (in US$) of Kenya in 1996 to that in 2001?
Offer a terse response. 1.02. What is the ratio of the Trade (in US$) in Maldives in 1996 to that in 2001?
Your answer should be very brief. 0.89. What is the ratio of the Trade (in US$) of Saudi Arabia in 1996 to that in 2001?
Your answer should be very brief. 0.87. What is the ratio of the Trade (in US$) in Turkmenistan in 1996 to that in 2001?
Give a very brief answer. 0.62. What is the ratio of the Trade (in US$) of Kenya in 1996 to that in 2002?
Your response must be concise. 0.93. What is the ratio of the Trade (in US$) in Maldives in 1996 to that in 2002?
Offer a terse response. 0.83. What is the ratio of the Trade (in US$) in Saudi Arabia in 1996 to that in 2002?
Provide a succinct answer. 0.82. What is the ratio of the Trade (in US$) in Turkmenistan in 1996 to that in 2002?
Offer a terse response. 0.58. What is the ratio of the Trade (in US$) in Kenya in 1997 to that in 1998?
Give a very brief answer. 1.05. What is the ratio of the Trade (in US$) in Maldives in 1997 to that in 1998?
Your answer should be compact. 0.93. What is the ratio of the Trade (in US$) in Saudi Arabia in 1997 to that in 1998?
Give a very brief answer. 1.49. What is the ratio of the Trade (in US$) of Turkmenistan in 1997 to that in 1998?
Provide a succinct answer. 1.23. What is the ratio of the Trade (in US$) in Kenya in 1997 to that in 1999?
Make the answer very short. 1.11. What is the ratio of the Trade (in US$) in Maldives in 1997 to that in 1999?
Provide a succinct answer. 0.87. What is the ratio of the Trade (in US$) in Saudi Arabia in 1997 to that in 1999?
Offer a very short reply. 1.16. What is the ratio of the Trade (in US$) of Turkmenistan in 1997 to that in 1999?
Your response must be concise. 0.76. What is the ratio of the Trade (in US$) in Kenya in 1997 to that in 2000?
Make the answer very short. 1.08. What is the ratio of the Trade (in US$) of Maldives in 1997 to that in 2000?
Provide a short and direct response. 0.83. What is the ratio of the Trade (in US$) in Saudi Arabia in 1997 to that in 2000?
Give a very brief answer. 0.79. What is the ratio of the Trade (in US$) of Turkmenistan in 1997 to that in 2000?
Your answer should be compact. 0.38. What is the ratio of the Trade (in US$) in Saudi Arabia in 1997 to that in 2001?
Make the answer very short. 0.89. What is the ratio of the Trade (in US$) in Turkmenistan in 1997 to that in 2001?
Keep it short and to the point. 0.36. What is the ratio of the Trade (in US$) in Kenya in 1997 to that in 2002?
Your answer should be very brief. 0.91. What is the ratio of the Trade (in US$) in Maldives in 1997 to that in 2002?
Offer a very short reply. 0.94. What is the ratio of the Trade (in US$) in Saudi Arabia in 1997 to that in 2002?
Ensure brevity in your answer.  0.84. What is the ratio of the Trade (in US$) in Turkmenistan in 1997 to that in 2002?
Provide a succinct answer. 0.34. What is the ratio of the Trade (in US$) in Kenya in 1998 to that in 1999?
Ensure brevity in your answer.  1.06. What is the ratio of the Trade (in US$) in Maldives in 1998 to that in 1999?
Your response must be concise. 0.94. What is the ratio of the Trade (in US$) in Saudi Arabia in 1998 to that in 1999?
Your answer should be compact. 0.78. What is the ratio of the Trade (in US$) of Turkmenistan in 1998 to that in 1999?
Provide a succinct answer. 0.62. What is the ratio of the Trade (in US$) of Kenya in 1998 to that in 2000?
Offer a very short reply. 1.04. What is the ratio of the Trade (in US$) of Maldives in 1998 to that in 2000?
Make the answer very short. 0.89. What is the ratio of the Trade (in US$) in Saudi Arabia in 1998 to that in 2000?
Give a very brief answer. 0.53. What is the ratio of the Trade (in US$) in Turkmenistan in 1998 to that in 2000?
Keep it short and to the point. 0.31. What is the ratio of the Trade (in US$) in Kenya in 1998 to that in 2001?
Give a very brief answer. 0.95. What is the ratio of the Trade (in US$) in Maldives in 1998 to that in 2001?
Your answer should be compact. 1.08. What is the ratio of the Trade (in US$) of Saudi Arabia in 1998 to that in 2001?
Make the answer very short. 0.6. What is the ratio of the Trade (in US$) in Turkmenistan in 1998 to that in 2001?
Your answer should be very brief. 0.3. What is the ratio of the Trade (in US$) in Kenya in 1998 to that in 2002?
Offer a very short reply. 0.87. What is the ratio of the Trade (in US$) in Maldives in 1998 to that in 2002?
Give a very brief answer. 1.01. What is the ratio of the Trade (in US$) of Saudi Arabia in 1998 to that in 2002?
Offer a terse response. 0.56. What is the ratio of the Trade (in US$) of Turkmenistan in 1998 to that in 2002?
Your response must be concise. 0.28. What is the ratio of the Trade (in US$) of Kenya in 1999 to that in 2000?
Offer a very short reply. 0.98. What is the ratio of the Trade (in US$) in Maldives in 1999 to that in 2000?
Your response must be concise. 0.95. What is the ratio of the Trade (in US$) in Saudi Arabia in 1999 to that in 2000?
Give a very brief answer. 0.68. What is the ratio of the Trade (in US$) of Turkmenistan in 1999 to that in 2000?
Offer a very short reply. 0.5. What is the ratio of the Trade (in US$) in Kenya in 1999 to that in 2001?
Provide a succinct answer. 0.9. What is the ratio of the Trade (in US$) of Maldives in 1999 to that in 2001?
Offer a very short reply. 1.15. What is the ratio of the Trade (in US$) of Saudi Arabia in 1999 to that in 2001?
Keep it short and to the point. 0.77. What is the ratio of the Trade (in US$) in Turkmenistan in 1999 to that in 2001?
Provide a short and direct response. 0.48. What is the ratio of the Trade (in US$) of Kenya in 1999 to that in 2002?
Keep it short and to the point. 0.82. What is the ratio of the Trade (in US$) in Maldives in 1999 to that in 2002?
Your response must be concise. 1.08. What is the ratio of the Trade (in US$) of Saudi Arabia in 1999 to that in 2002?
Your answer should be compact. 0.72. What is the ratio of the Trade (in US$) of Turkmenistan in 1999 to that in 2002?
Your response must be concise. 0.45. What is the ratio of the Trade (in US$) of Kenya in 2000 to that in 2001?
Give a very brief answer. 0.92. What is the ratio of the Trade (in US$) of Maldives in 2000 to that in 2001?
Keep it short and to the point. 1.2. What is the ratio of the Trade (in US$) in Saudi Arabia in 2000 to that in 2001?
Make the answer very short. 1.13. What is the ratio of the Trade (in US$) of Turkmenistan in 2000 to that in 2001?
Your answer should be compact. 0.96. What is the ratio of the Trade (in US$) of Kenya in 2000 to that in 2002?
Give a very brief answer. 0.84. What is the ratio of the Trade (in US$) of Maldives in 2000 to that in 2002?
Give a very brief answer. 1.13. What is the ratio of the Trade (in US$) in Saudi Arabia in 2000 to that in 2002?
Make the answer very short. 1.06. What is the ratio of the Trade (in US$) in Turkmenistan in 2000 to that in 2002?
Your answer should be compact. 0.9. What is the ratio of the Trade (in US$) in Kenya in 2001 to that in 2002?
Make the answer very short. 0.91. What is the ratio of the Trade (in US$) of Maldives in 2001 to that in 2002?
Ensure brevity in your answer.  0.94. What is the ratio of the Trade (in US$) of Saudi Arabia in 2001 to that in 2002?
Offer a very short reply. 0.94. What is the ratio of the Trade (in US$) in Turkmenistan in 2001 to that in 2002?
Ensure brevity in your answer.  0.93. What is the difference between the highest and the second highest Trade (in US$) in Kenya?
Your answer should be compact. 2.38e+08. What is the difference between the highest and the second highest Trade (in US$) of Maldives?
Your answer should be compact. 2.53e+07. What is the difference between the highest and the second highest Trade (in US$) in Saudi Arabia?
Give a very brief answer. 4.62e+09. What is the difference between the highest and the second highest Trade (in US$) of Turkmenistan?
Ensure brevity in your answer.  2.04e+08. What is the difference between the highest and the lowest Trade (in US$) of Kenya?
Provide a short and direct response. 5.87e+08. What is the difference between the highest and the lowest Trade (in US$) of Maldives?
Your response must be concise. 1.46e+08. What is the difference between the highest and the lowest Trade (in US$) in Saudi Arabia?
Offer a very short reply. 3.88e+1. What is the difference between the highest and the lowest Trade (in US$) in Turkmenistan?
Your response must be concise. 2.23e+09. 